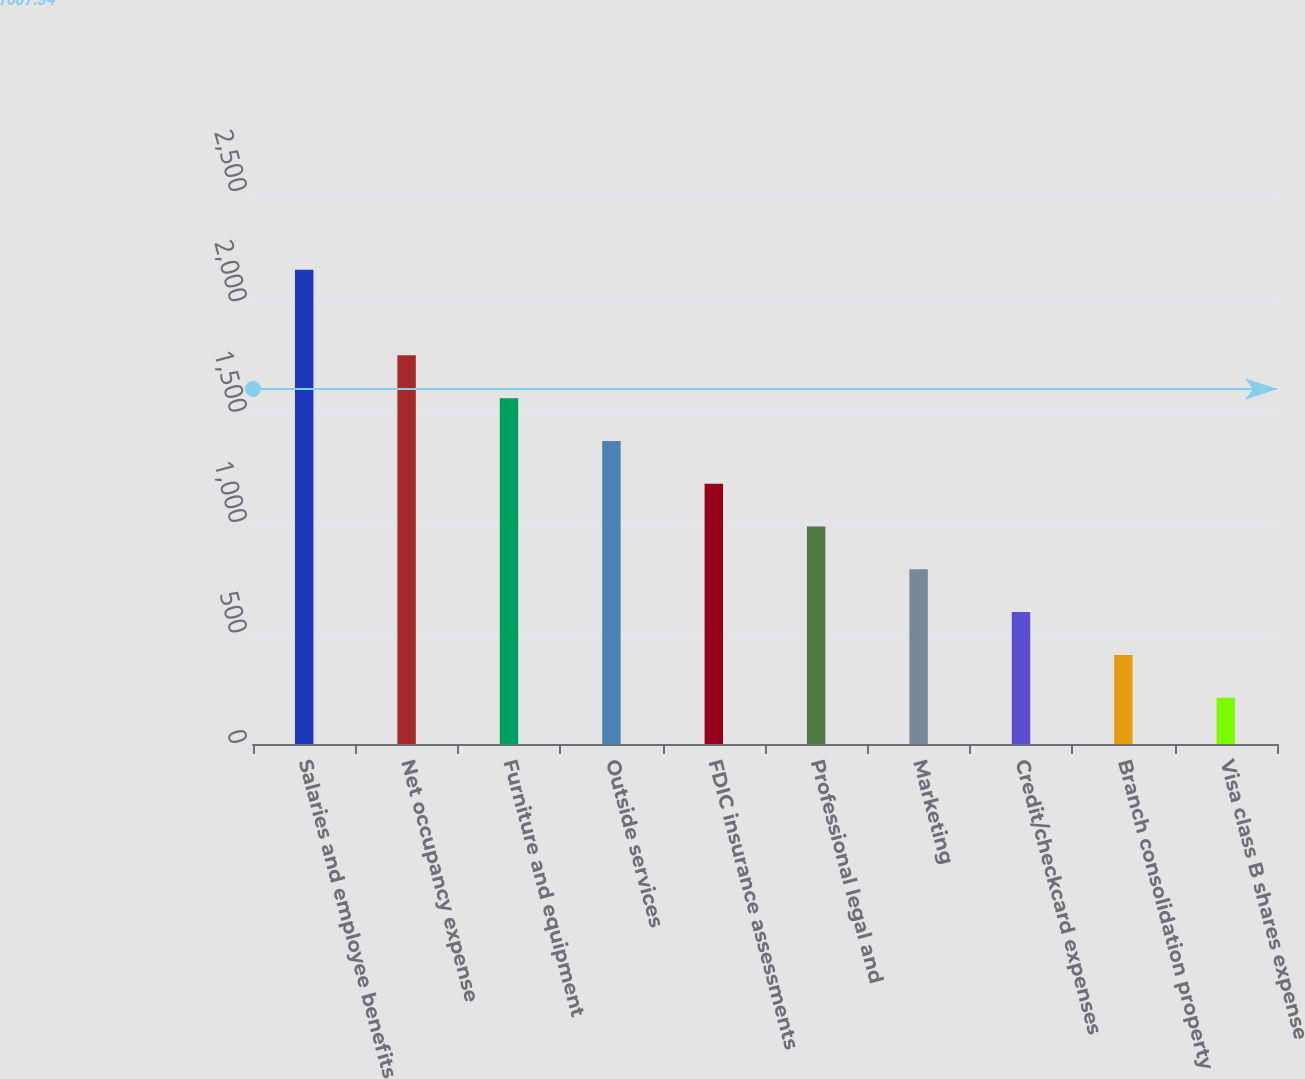Convert chart. <chart><loc_0><loc_0><loc_500><loc_500><bar_chart><fcel>Salaries and employee benefits<fcel>Net occupancy expense<fcel>Furniture and equipment<fcel>Outside services<fcel>FDIC insurance assessments<fcel>Professional legal and<fcel>Marketing<fcel>Credit/checkcard expenses<fcel>Branch consolidation property<fcel>Visa class B shares expense<nl><fcel>2147.8<fcel>1760.2<fcel>1566.4<fcel>1372.6<fcel>1178.8<fcel>985<fcel>791.2<fcel>597.4<fcel>403.6<fcel>209.8<nl></chart> 